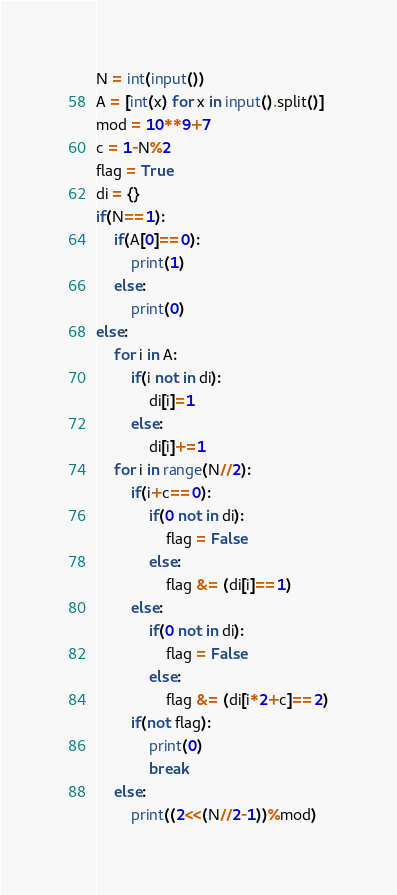Convert code to text. <code><loc_0><loc_0><loc_500><loc_500><_Python_>N = int(input())
A = [int(x) for x in input().split()]
mod = 10**9+7
c = 1-N%2
flag = True
di = {}
if(N==1):
    if(A[0]==0):
        print(1)
    else:
        print(0)
else:
    for i in A:
        if(i not in di):
            di[i]=1
        else:
            di[i]+=1
    for i in range(N//2):
        if(i+c==0):
            if(0 not in di):
                flag = False
            else:
                flag &= (di[i]==1)
        else:
            if(0 not in di):
                flag = False
            else:
                flag &= (di[i*2+c]==2)
        if(not flag):
            print(0)
            break
    else:
        print((2<<(N//2-1))%mod)
</code> 